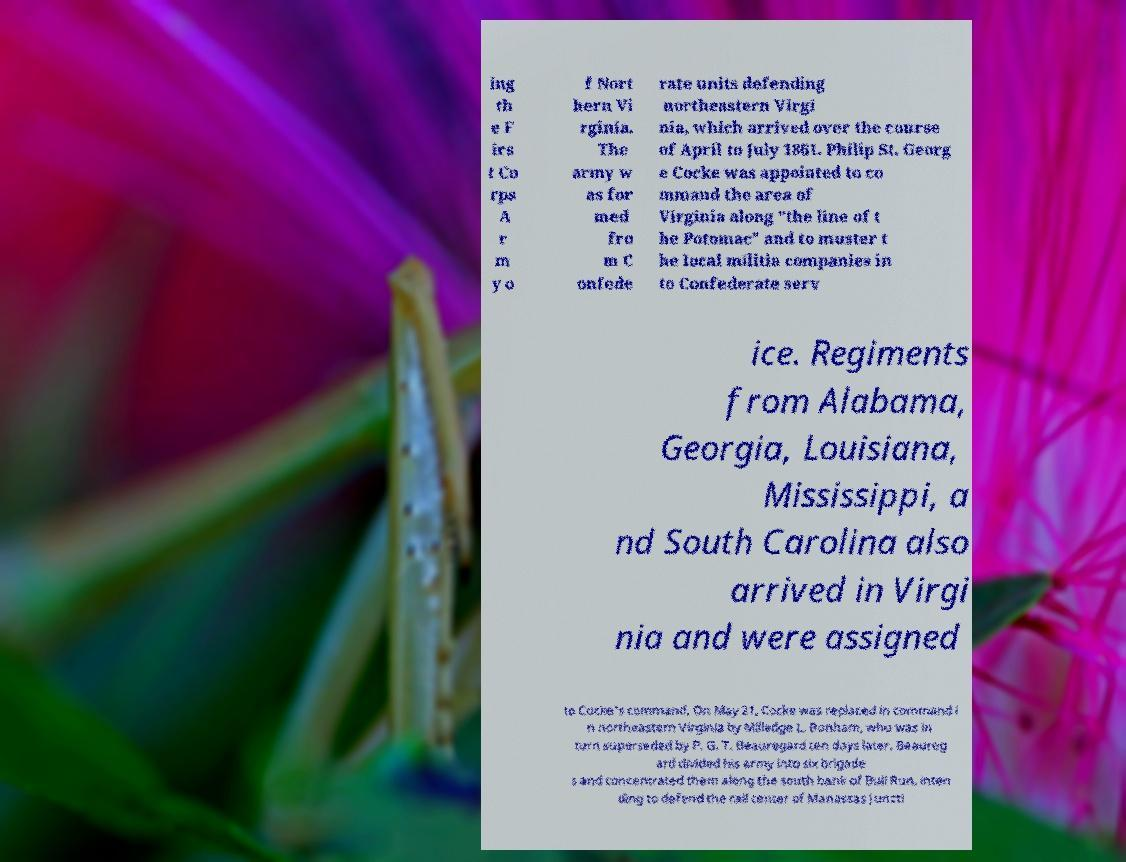Can you read and provide the text displayed in the image?This photo seems to have some interesting text. Can you extract and type it out for me? ing th e F irs t Co rps A r m y o f Nort hern Vi rginia. The army w as for med fro m C onfede rate units defending northeastern Virgi nia, which arrived over the course of April to July 1861. Philip St. Georg e Cocke was appointed to co mmand the area of Virginia along "the line of t he Potomac" and to muster t he local militia companies in to Confederate serv ice. Regiments from Alabama, Georgia, Louisiana, Mississippi, a nd South Carolina also arrived in Virgi nia and were assigned to Cocke's command. On May 21, Cocke was replaced in command i n northeastern Virginia by Milledge L. Bonham, who was in turn superseded by P. G. T. Beauregard ten days later. Beaureg ard divided his army into six brigade s and concentrated them along the south bank of Bull Run, inten ding to defend the rail center of Manassas Juncti 